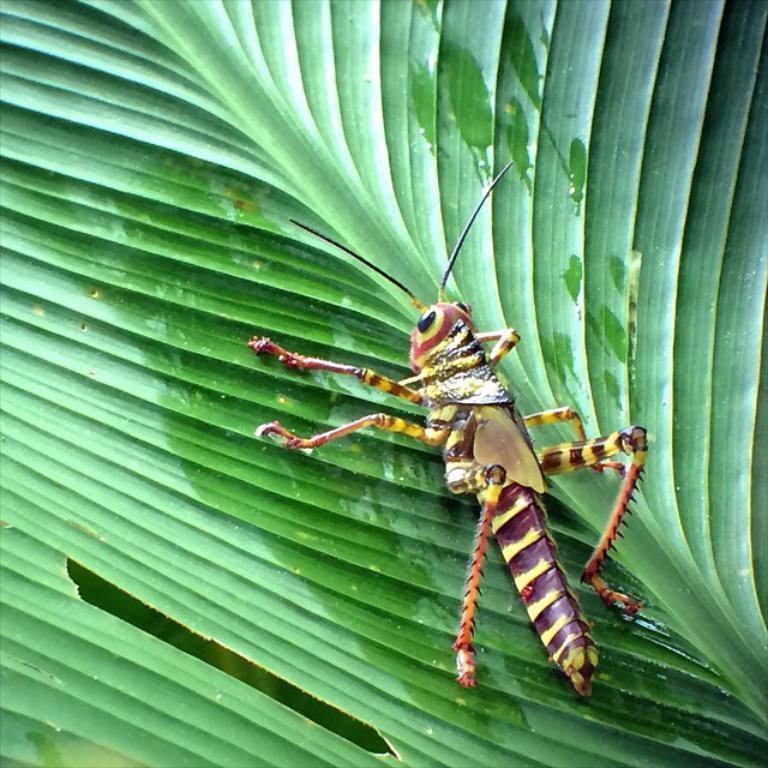In one or two sentences, can you explain what this image depicts? In this image I can see an insect on a green color leaf. 